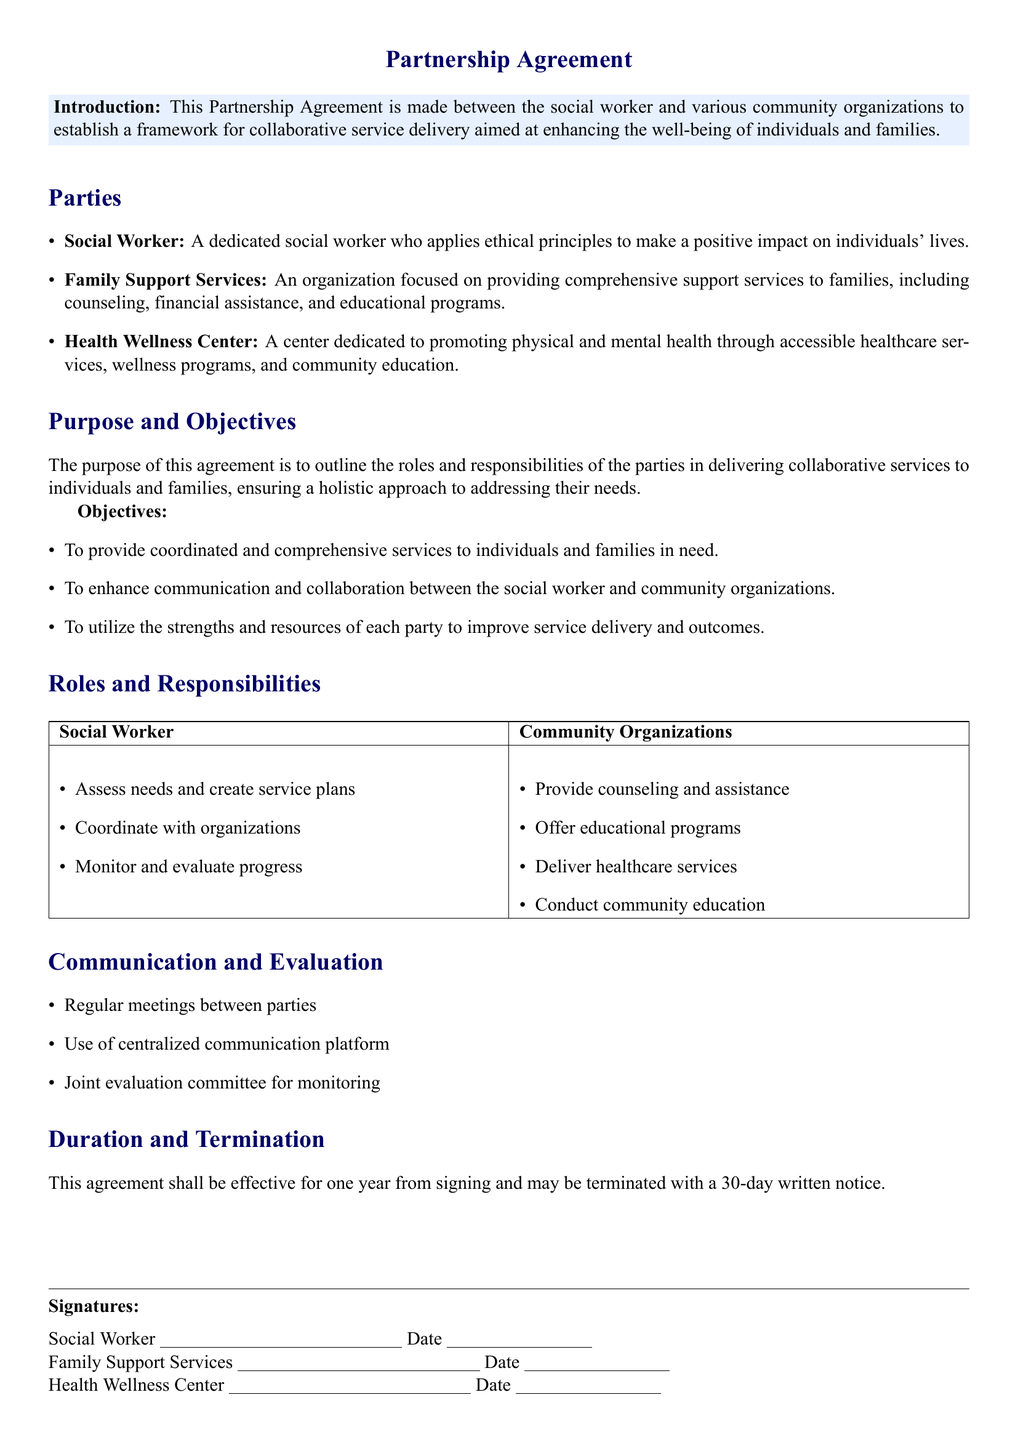What is the title of the document? The title describes the main subject of the document, which establishes the partnership for service delivery.
Answer: Partnership Agreement Who are the three parties involved in this agreement? The parties include the social worker and two organizations involved in community services.
Answer: Social Worker, Family Support Services, Health Wellness Center What is one objective of the partnership agreement? The objective focuses on enhancing collaboration and service delivery among the involved parties.
Answer: To provide coordinated and comprehensive services How long is the duration of the agreement? The duration specifies the time frame for which the agreement is valid before renewal or termination is necessary.
Answer: One year What is required for termination of the agreement? The document outlines the process necessary to end the agreement between parties.
Answer: 30-day written notice What type of evaluations are mentioned in the agreement? This refers to the nature of the processes that will be used to assess the effectiveness of the partnership.
Answer: Joint evaluation committee What are the community organizations expected to provide? The responsibilities of the community organizations include delivering specific services outlined in the agreement.
Answer: Counseling and assistance What is included in the communication strategy? This refers to the systematic approach outlined for how the parties will connect regarding their services.
Answer: Regular meetings between parties 